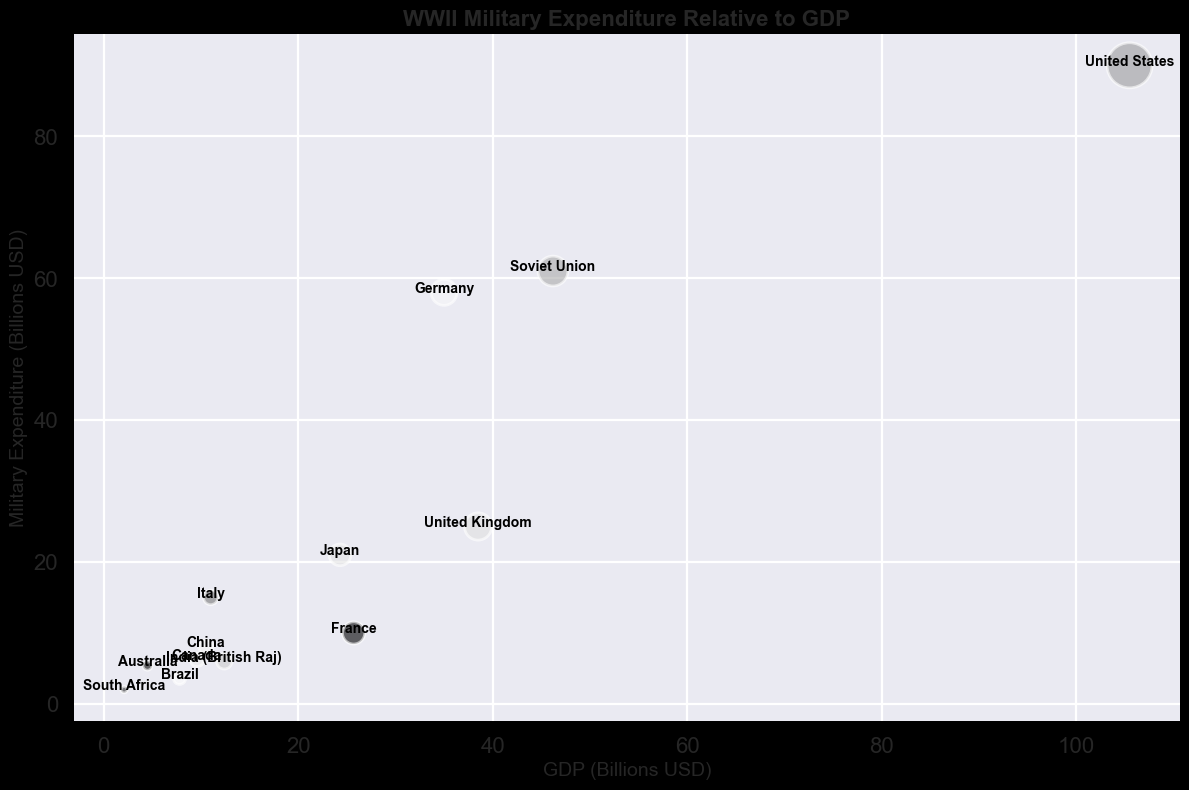What country has the highest military expenditure? On the bubble chart, identify which bubble is placed at the highest point on the y-axis (military expenditure). The United States has the highest military expenditure at 90.0 billion USD.
Answer: United States Which country has a greater GDP, Germany or Japan? Look at the positions of the bubbles representing Germany and Japan along the x-axis (GDP). Germany's GDP is 35.0 billion USD, while Japan's GDP is 24.3 billion USD.
Answer: Germany What is the total military expenditure of the Soviet Union and Japan combined? First, locate the military expenditures of the Soviet Union (61.0 billion USD) and Japan (21.0 billion USD) separately on the y-axis. Then, add the two values together: 61.0 + 21.0 = 82.0 billion USD.
Answer: 82.0 Which country has a larger bubble, France or India (British Raj)? Compare the sizes of the bubbles representing France and India (British Raj). The bubble size corresponds to their GDP, with France having a GDP of 25.7 billion USD and India (British Raj) having a GDP of 12.4 billion USD. Therefore, France has a larger bubble.
Answer: France Between Canada and Australia, which country spent more on military expenditures? Locate the bubbles for Canada and Australia and compare their positions along the y-axis (military expenditure). Canada has a military expenditure of 6.2 billion USD, while Australia has a military expenditure of 5.4 billion USD.
Answer: Canada What is the difference in military expenditure between the United Kingdom and Italy? Identify the military expenditures for the United Kingdom (25.0 billion USD) and Italy (15.0 billion USD) and subtract the smaller amount from the larger amount: 25.0 - 15.0 = 10.0 billion USD.
Answer: 10.0 How does the GDP of the Soviet Union compare to that of the United States? Compare the bubbles for the Soviet Union and the United States along the x-axis. The United States has a GDP of 105.5 billion USD, while the Soviet Union has a GDP of 46.2 billion USD. The United States has a significantly higher GDP.
Answer: United States Which country has the smallest military expenditure relative to its GDP? Calculate the ratio of military expenditure to GDP for each country and compare them. For South Africa, the ratio is 2.0/2.1 ≈ 0.95. Perform similar calculations for other countries to confirm that South Africa has the smallest ratio.
Answer: South Africa What is the average GDP of the countries represented in the chart? Sum up the GDP of all the countries and then divide by the number of countries. GDP sum: 105.5 + 35.0 + 38.5 + 46.2 + 24.3 + 11.0 + 25.7 + 9.6 + 4.5 + 10.5 + 12.4 + 7.8 + 2.1 = 333.1 billion USD. Number of countries: 13. Average GDP = 333.1/13 ≈ 25.6 billion USD.
Answer: 25.6 